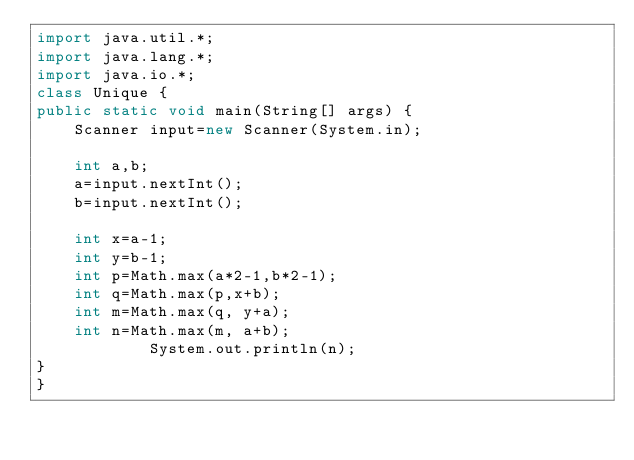Convert code to text. <code><loc_0><loc_0><loc_500><loc_500><_Java_>import java.util.*;
import java.lang.*;
import java.io.*;
class Unique {
public static void main(String[] args) {
	Scanner input=new Scanner(System.in);

	int a,b;
	a=input.nextInt();
	b=input.nextInt();

	int x=a-1;
	int y=b-1;
	int p=Math.max(a*2-1,b*2-1);
	int q=Math.max(p,x+b);
	int m=Math.max(q, y+a);
	int n=Math.max(m, a+b);
			System.out.println(n);
}
}
</code> 